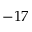Convert formula to latex. <formula><loc_0><loc_0><loc_500><loc_500>- 1 7</formula> 